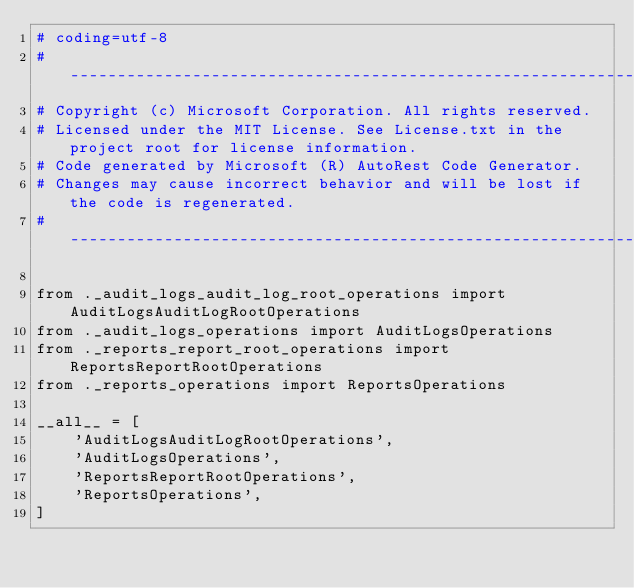<code> <loc_0><loc_0><loc_500><loc_500><_Python_># coding=utf-8
# --------------------------------------------------------------------------
# Copyright (c) Microsoft Corporation. All rights reserved.
# Licensed under the MIT License. See License.txt in the project root for license information.
# Code generated by Microsoft (R) AutoRest Code Generator.
# Changes may cause incorrect behavior and will be lost if the code is regenerated.
# --------------------------------------------------------------------------

from ._audit_logs_audit_log_root_operations import AuditLogsAuditLogRootOperations
from ._audit_logs_operations import AuditLogsOperations
from ._reports_report_root_operations import ReportsReportRootOperations
from ._reports_operations import ReportsOperations

__all__ = [
    'AuditLogsAuditLogRootOperations',
    'AuditLogsOperations',
    'ReportsReportRootOperations',
    'ReportsOperations',
]
</code> 